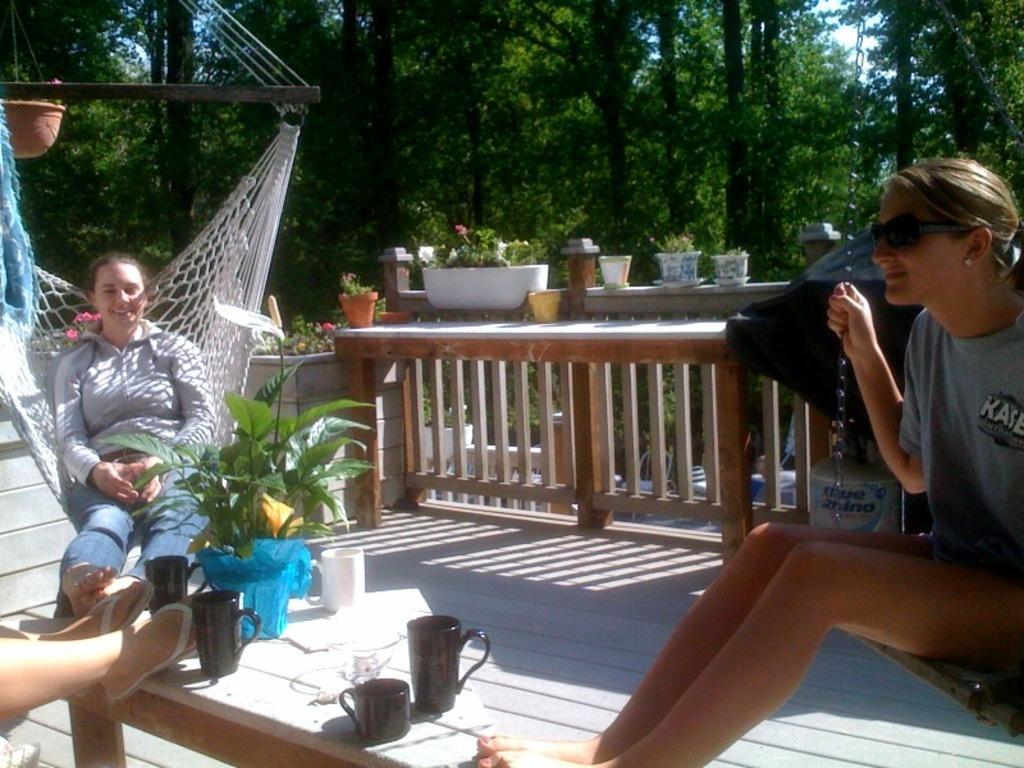In one or two sentences, can you explain what this image depicts? As we can see in the image there is a net, plant and two people. In the background there are trees. In the front there is a table. On table there are cups, plant and a pot. 